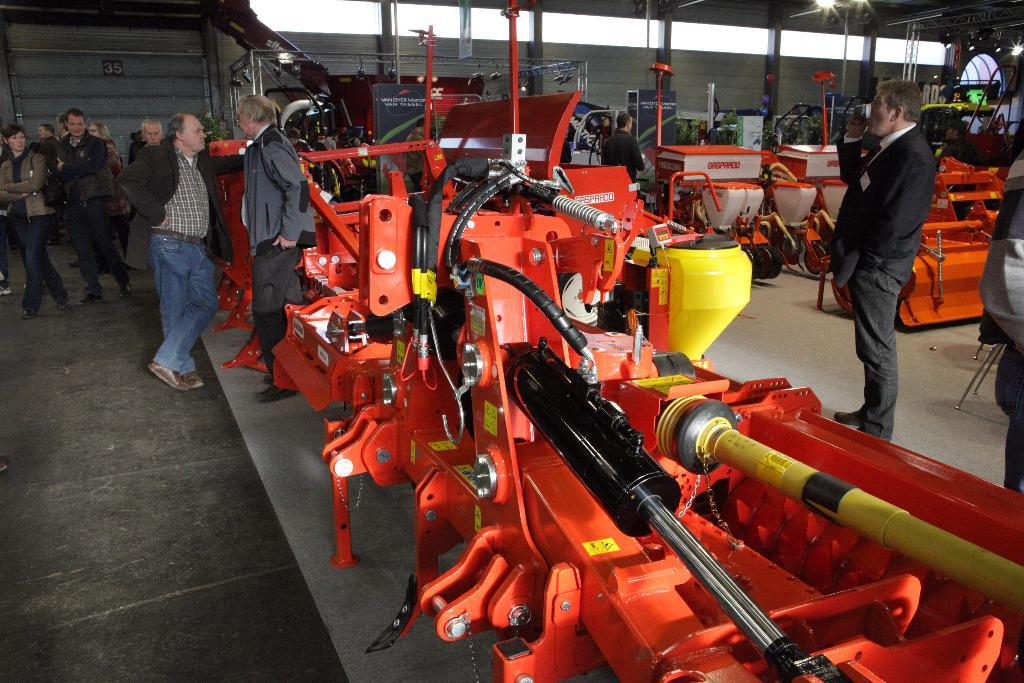How many people are in the image? There is a group of people in the image, but the exact number is not specified. What are the people in the image doing? Some people are standing, while others are walking. What can be seen in the image besides the people? There are machines visible in the image. What is visible in the background of the image? There are lights and a wall in the background of the image. How many worms can be seen crawling on the machines in the image? There are no worms visible in the image. What type of earthquake is happening in the image? There is no indication of an earthquake in the image. 